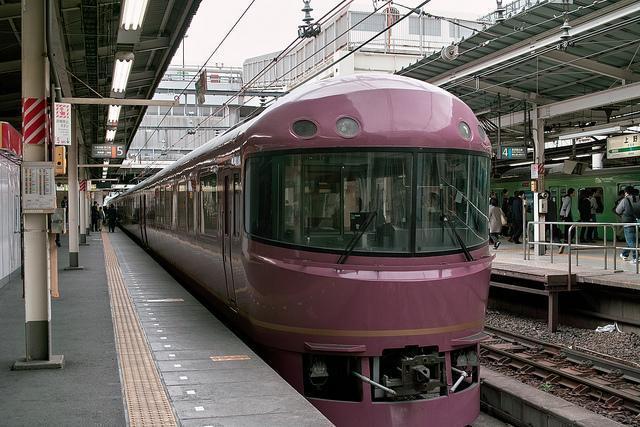How many trains are in the picture?
Give a very brief answer. 2. 